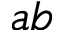Convert formula to latex. <formula><loc_0><loc_0><loc_500><loc_500>a b</formula> 